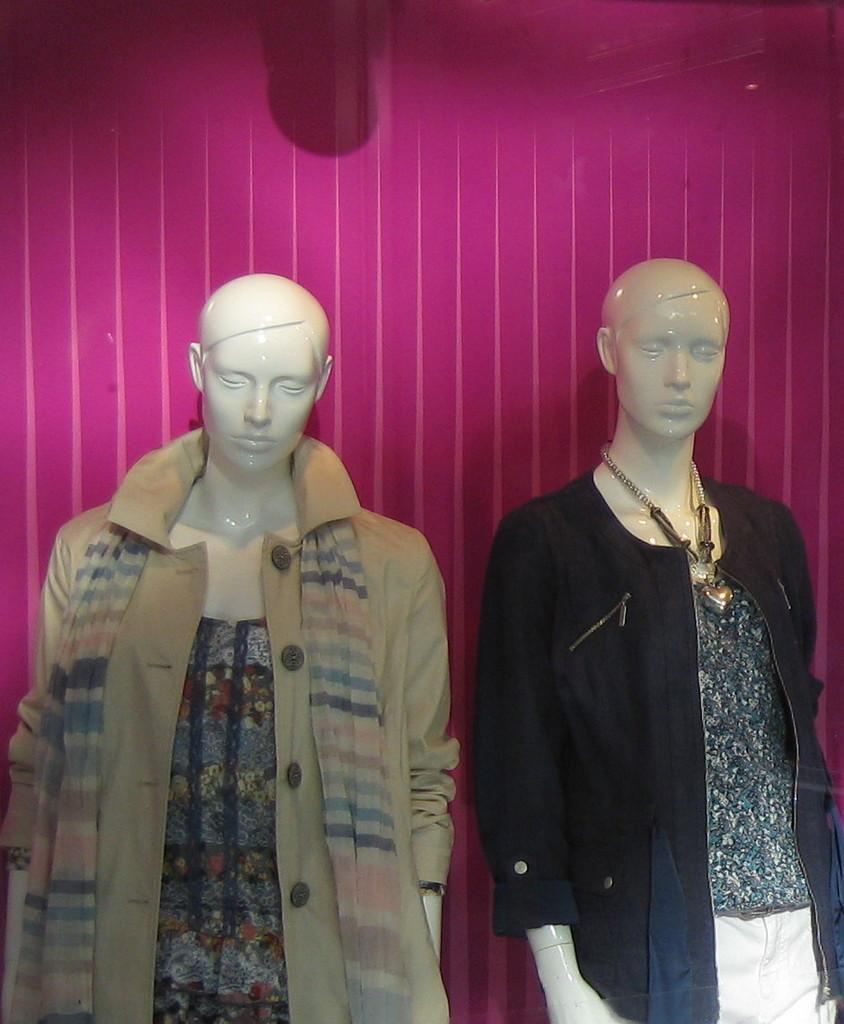How many mannequins are present in the image? There are two mannequins in the image. What are the mannequins wearing? Both mannequins are wearing jackets. Can you describe any additional accessories on the mannequins? One of the mannequins has a chain around its neck. How many ducks are sitting on the beds in the image? There are no ducks or beds present in the image; it features two mannequins wearing jackets and one with a chain around its neck. 